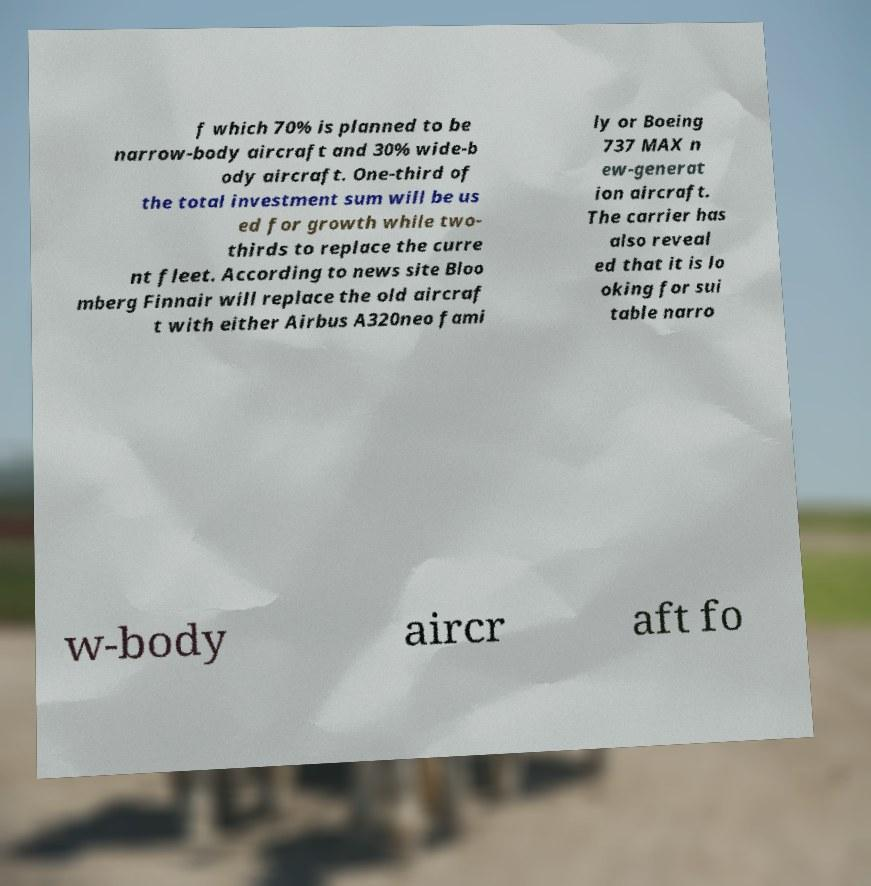Could you assist in decoding the text presented in this image and type it out clearly? f which 70% is planned to be narrow-body aircraft and 30% wide-b ody aircraft. One-third of the total investment sum will be us ed for growth while two- thirds to replace the curre nt fleet. According to news site Bloo mberg Finnair will replace the old aircraf t with either Airbus A320neo fami ly or Boeing 737 MAX n ew-generat ion aircraft. The carrier has also reveal ed that it is lo oking for sui table narro w-body aircr aft fo 